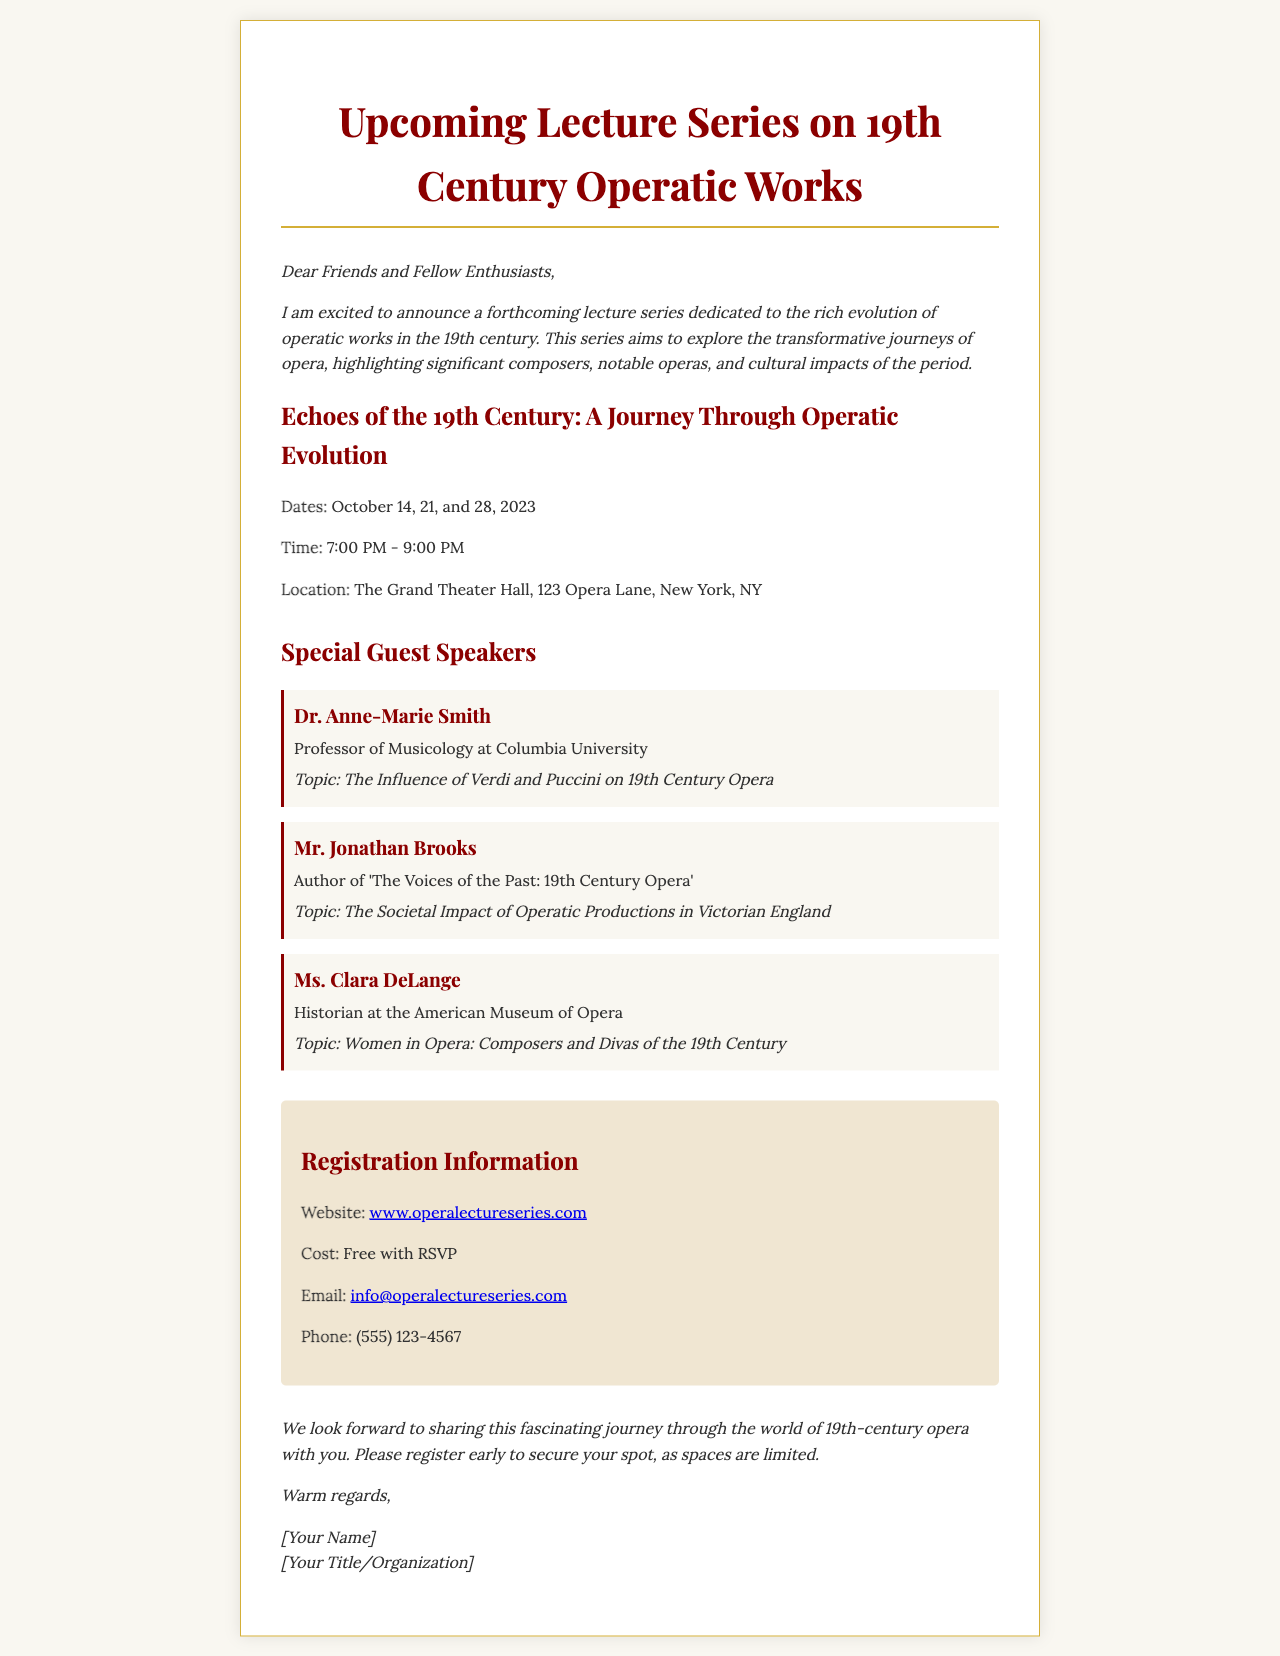what are the dates of the lecture series? The dates of the lecture series are explicitly provided in the document, which lists October 14, 21, and 28, 2023.
Answer: October 14, 21, and 28, 2023 who is the first guest speaker? The document clearly states the name of the first guest speaker in the list, which is Dr. Anne-Marie Smith.
Answer: Dr. Anne-Marie Smith what topic will Mr. Jonathan Brooks discuss? The document includes the specific topic assigned to Mr. Jonathan Brooks, detailing that it focuses on the societal impact of operatic productions.
Answer: The Societal Impact of Operatic Productions in Victorian England what is the registration cost? The document specifies the cost for registration, indicating that it is free with RSVP.
Answer: Free with RSVP what is the location of the lectures? The document provides detailed information about the location where the lectures will be held, specifically naming The Grand Theater Hall and its address.
Answer: The Grand Theater Hall, 123 Opera Lane, New York, NY how long will each lecture last? The duration of each lecture is mentioned in the document under the time section, which indicates they will last for two hours.
Answer: 2 hours who is the email contact for inquiries? The document includes a contact email for inquiries related to the lecture series, clearly listing info@operalectureseries.com.
Answer: info@operalectureseries.com what is the organization that Dr. Anne-Marie Smith is associated with? The document mentions that Dr. Anne-Marie Smith is a professor at Columbia University, which defines her association.
Answer: Columbia University 